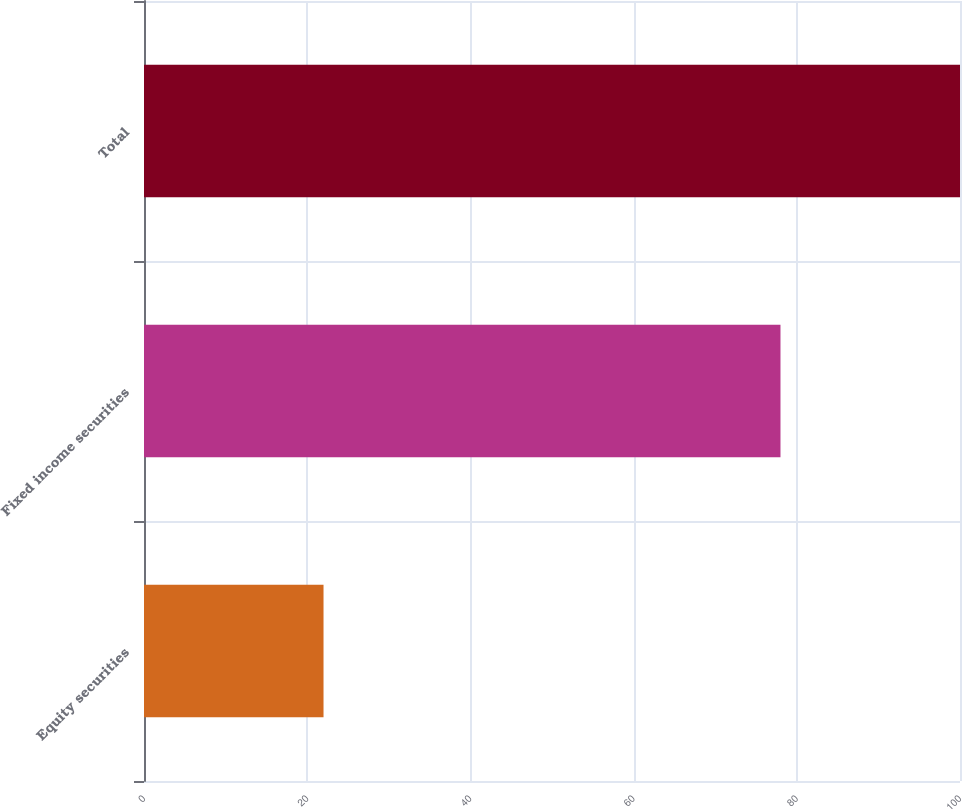Convert chart to OTSL. <chart><loc_0><loc_0><loc_500><loc_500><bar_chart><fcel>Equity securities<fcel>Fixed income securities<fcel>Total<nl><fcel>22<fcel>78<fcel>100<nl></chart> 